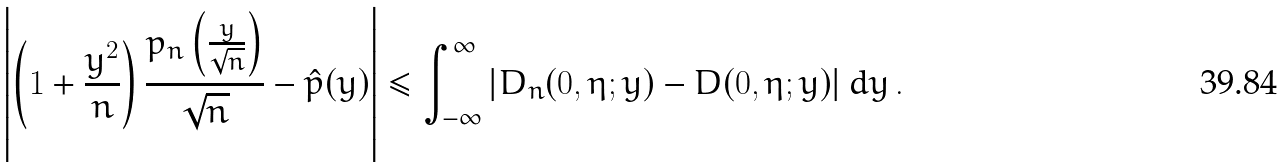Convert formula to latex. <formula><loc_0><loc_0><loc_500><loc_500>\left | \left ( 1 + \frac { y ^ { 2 } } { n } \right ) \frac { p _ { n } \left ( \frac { y } { \sqrt { n } } \right ) } { \sqrt { n } } - \hat { p } ( y ) \right | \leq \int _ { - \infty } ^ { \infty } \left | D _ { n } ( 0 , \eta ; y ) - D ( 0 , \eta ; y ) \right | d y \, .</formula> 